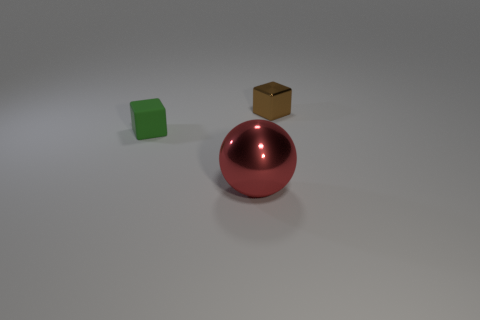If these objects were part of a game, what might the rules be? If these objects were part of a game, it could involve spatial reasoning puzzles where the player needs to fit the objects into corresponding slots based on their shapes, or perhaps a balancing game where the goal is to stack them without toppling over. 